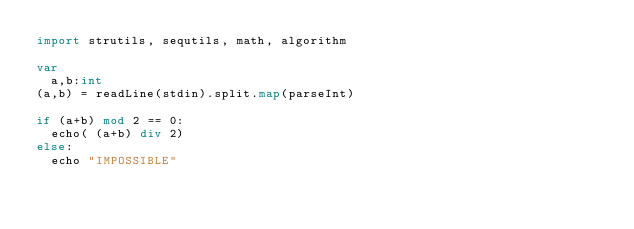<code> <loc_0><loc_0><loc_500><loc_500><_Nim_>import strutils, sequtils, math, algorithm

var
  a,b:int
(a,b) = readLine(stdin).split.map(parseInt)

if (a+b) mod 2 == 0:
  echo( (a+b) div 2)
else:
  echo "IMPOSSIBLE"
</code> 